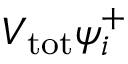Convert formula to latex. <formula><loc_0><loc_0><loc_500><loc_500>V _ { t o t } \psi _ { i } ^ { + }</formula> 